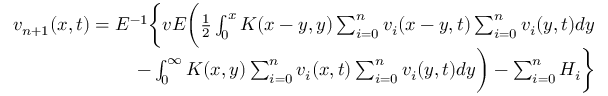Convert formula to latex. <formula><loc_0><loc_0><loc_500><loc_500>\begin{array} { r } { v _ { n + 1 } ( x , t ) = E ^ { - 1 } \left \{ v E \left ( \frac { 1 } { 2 } \int _ { 0 } ^ { x } K ( x - y , y ) \sum _ { i = 0 } ^ { n } v _ { i } ( x - y , t ) \sum _ { i = 0 } ^ { n } v _ { i } ( y , t ) d y } \\ { - \int _ { 0 } ^ { \infty } K ( x , y ) \sum _ { i = 0 } ^ { n } v _ { i } ( x , t ) \sum _ { i = 0 } ^ { n } v _ { i } ( y , t ) d y \right ) - \sum _ { i = 0 } ^ { n } H _ { i } \right \} } \end{array}</formula> 